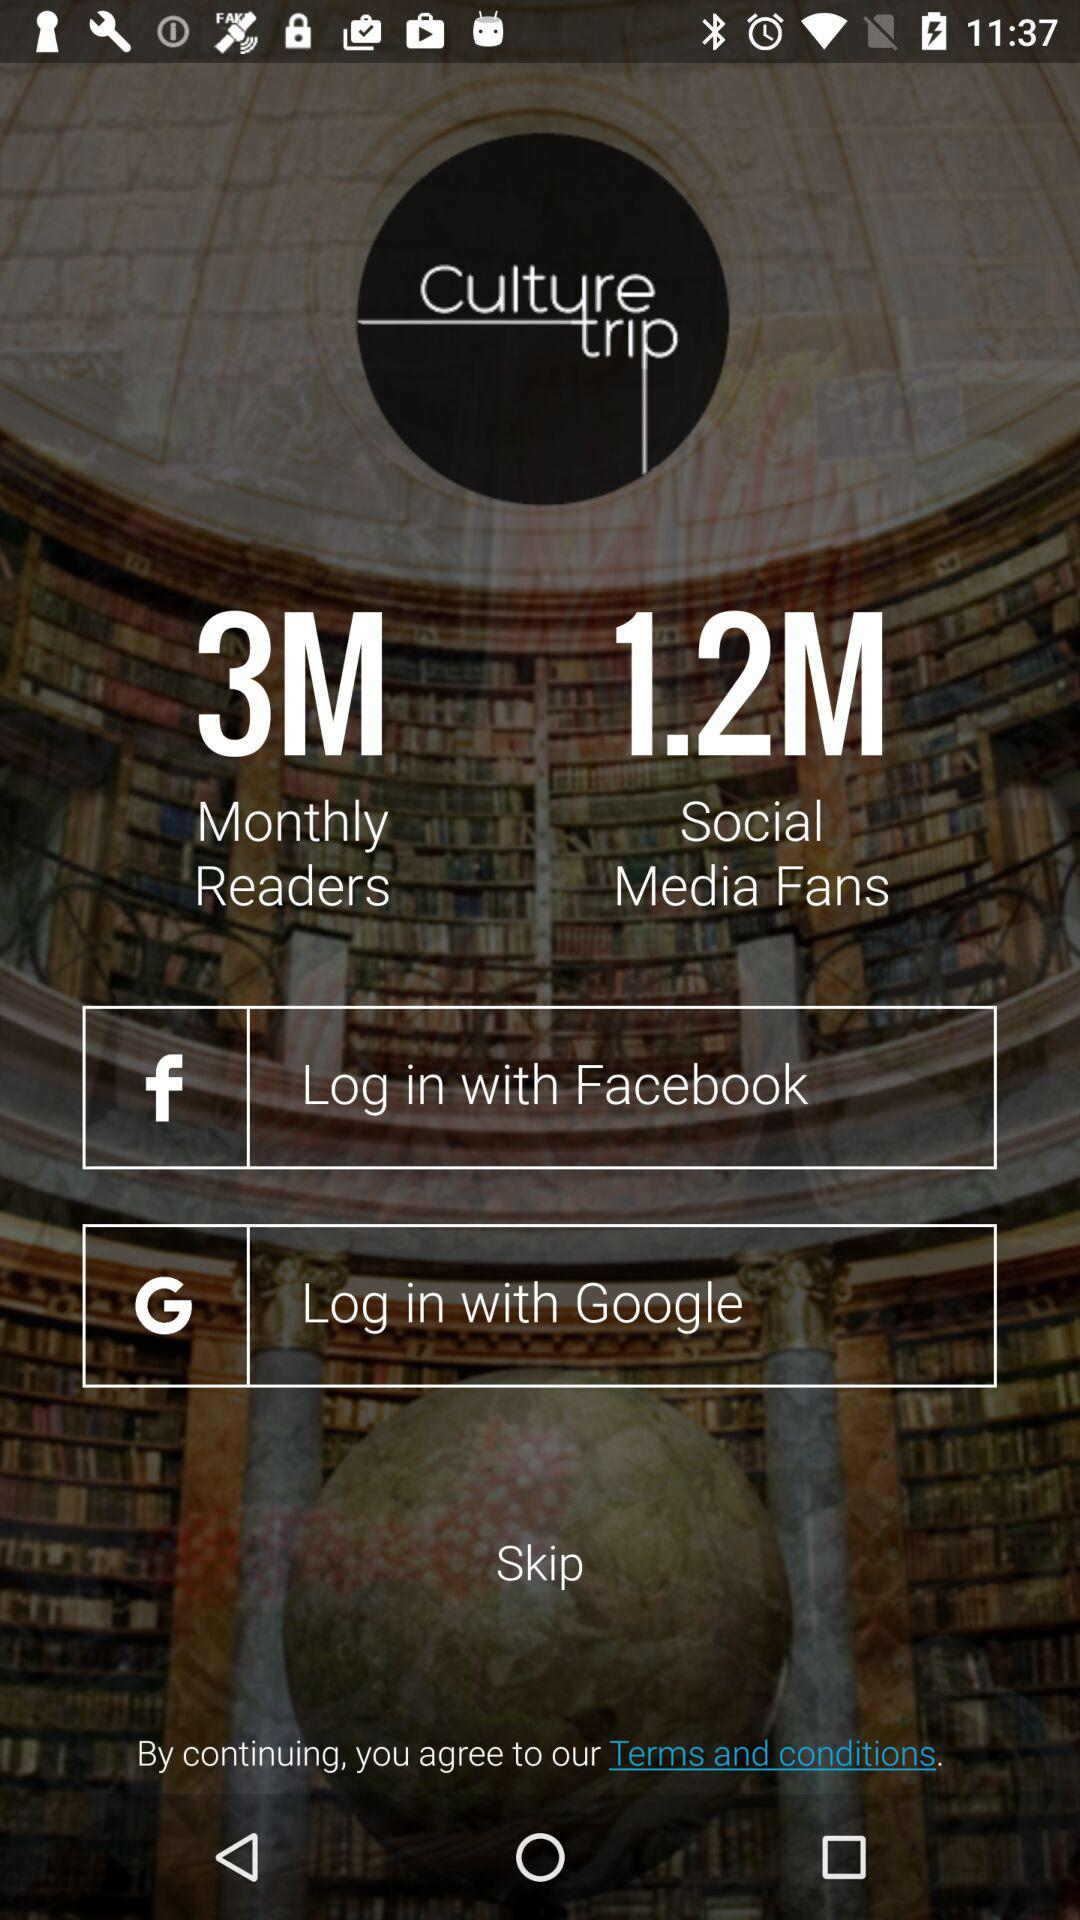Through what application is the person logging in? The person is logging in through "Facebook". 